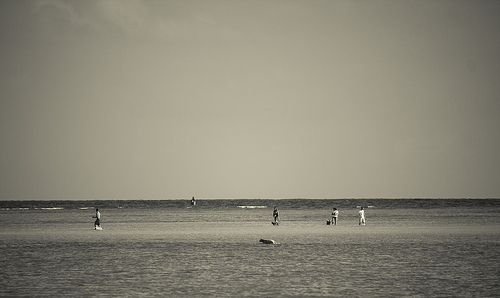The board is white. The white board in the image is situated in the upper half of the scene, serving as a background likely for beach activities. 